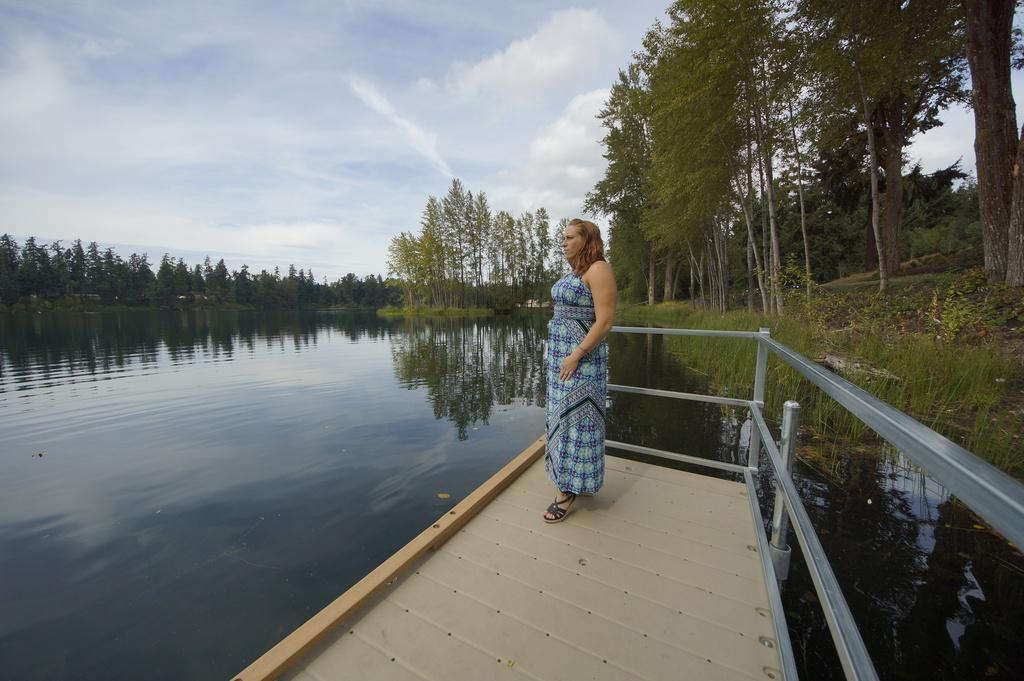What is the person in the image doing? The person is standing on the bridge. What feature is present on the bridge? There is a railing on the bridge. What can be seen in the background of the image? Trees, water, and the sky are visible in the background of the image. What is the condition of the sky in the image? Clouds are present in the sky. What type of toothbrush is the secretary using in the image? There is no secretary or toothbrush present in the image. 